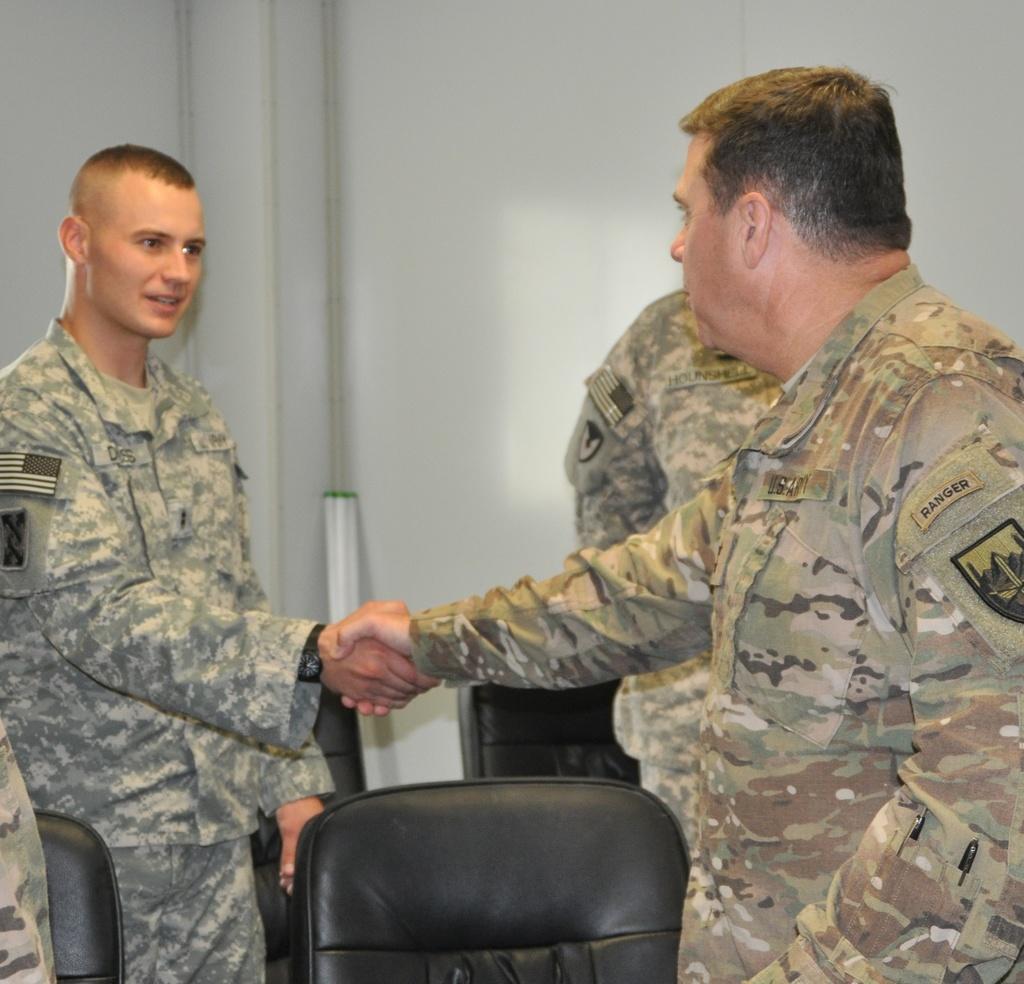How would you summarize this image in a sentence or two? In this picture there are two men standing. They both are wearing uniform. And they are shaking hands each other. There are black color chairs. 